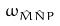<formula> <loc_0><loc_0><loc_500><loc_500>\omega _ { \hat { M } \hat { N } P }</formula> 